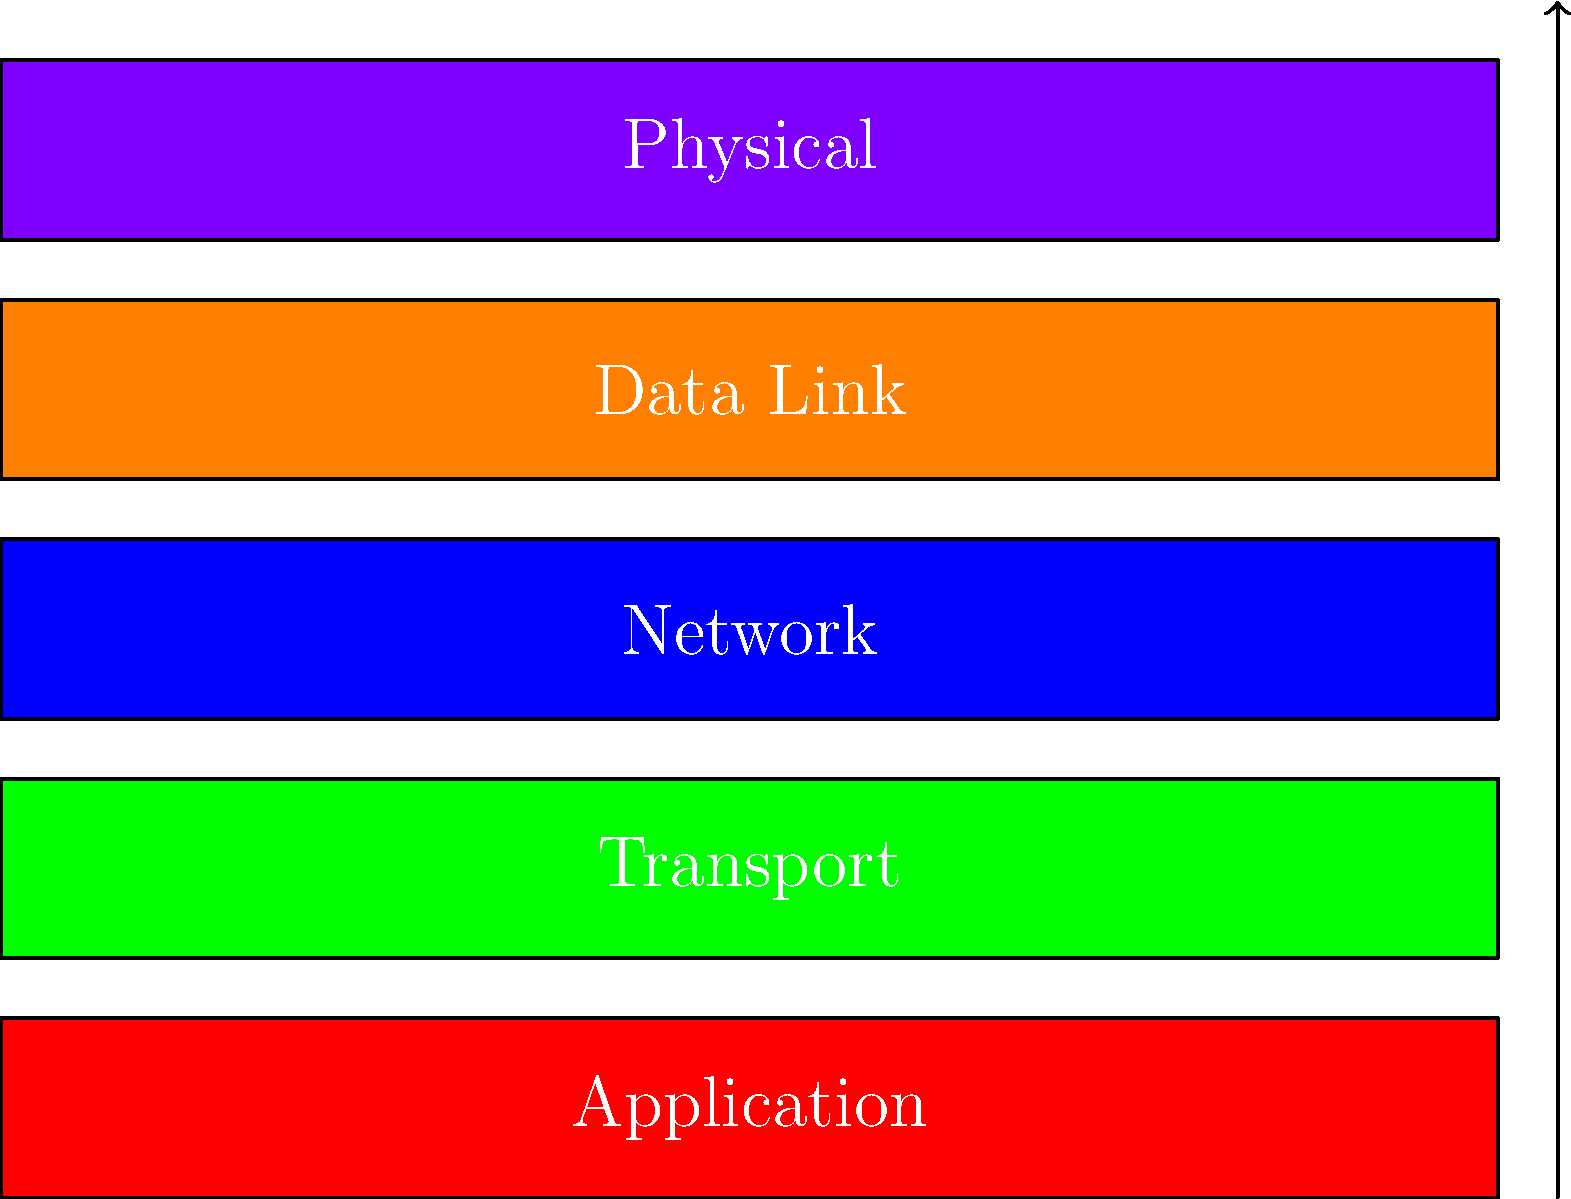In the OSI model diagram shown above, which layer is responsible for routing data packets between different networks? To answer this question, let's break down the OSI (Open Systems Interconnection) model layers and their functions:

1. Physical Layer (Bottom): Deals with the physical transmission of data bits over a medium.
2. Data Link Layer: Handles error-free transfer of data frames between two nodes.
3. Network Layer: Responsible for routing data packets between different networks.
4. Transport Layer: Ensures end-to-end communication and data integrity.
5. Application Layer (Top): Provides network services directly to end-users or applications.

The key function we're looking for is "routing data packets between different networks." This is a primary responsibility of the Network Layer, which is the middle layer in the diagram (colored blue).

The Network Layer uses logical addressing (like IP addresses) to determine the best path for data to travel from the source to the destination, potentially across multiple networks. This routing functionality is crucial for internet communication and is not handled by any other layer in the OSI model.
Answer: Network Layer 